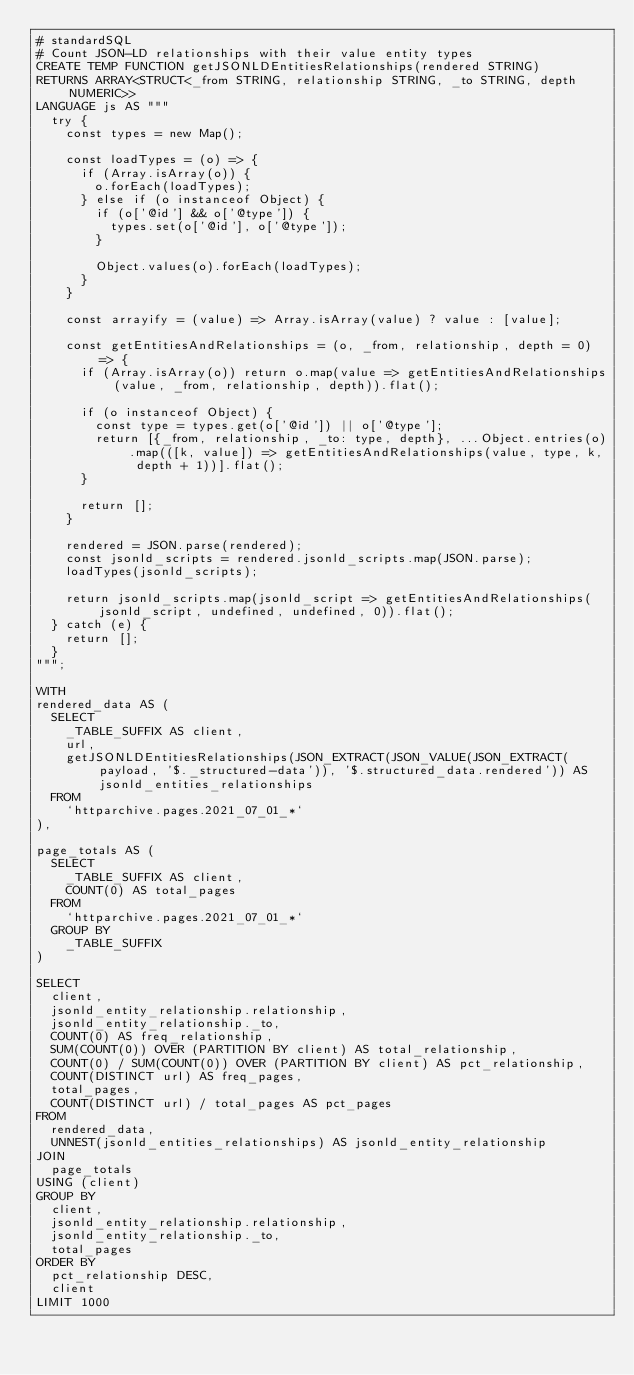<code> <loc_0><loc_0><loc_500><loc_500><_SQL_># standardSQL
# Count JSON-LD relationships with their value entity types
CREATE TEMP FUNCTION getJSONLDEntitiesRelationships(rendered STRING)
RETURNS ARRAY<STRUCT<_from STRING, relationship STRING, _to STRING, depth NUMERIC>>
LANGUAGE js AS """
  try {
    const types = new Map();

    const loadTypes = (o) => {
      if (Array.isArray(o)) {
        o.forEach(loadTypes);
      } else if (o instanceof Object) {
        if (o['@id'] && o['@type']) {
          types.set(o['@id'], o['@type']);
        }

        Object.values(o).forEach(loadTypes);
      }
    }

    const arrayify = (value) => Array.isArray(value) ? value : [value];

    const getEntitiesAndRelationships = (o, _from, relationship, depth = 0) => {
      if (Array.isArray(o)) return o.map(value => getEntitiesAndRelationships(value, _from, relationship, depth)).flat();

      if (o instanceof Object) {
        const type = types.get(o['@id']) || o['@type'];
        return [{_from, relationship, _to: type, depth}, ...Object.entries(o).map(([k, value]) => getEntitiesAndRelationships(value, type, k, depth + 1))].flat();
      }

      return [];
    }

    rendered = JSON.parse(rendered);
    const jsonld_scripts = rendered.jsonld_scripts.map(JSON.parse);
    loadTypes(jsonld_scripts);

    return jsonld_scripts.map(jsonld_script => getEntitiesAndRelationships(jsonld_script, undefined, undefined, 0)).flat();
  } catch (e) {
    return [];
  }
""";

WITH
rendered_data AS (
  SELECT
    _TABLE_SUFFIX AS client,
    url,
    getJSONLDEntitiesRelationships(JSON_EXTRACT(JSON_VALUE(JSON_EXTRACT(payload, '$._structured-data')), '$.structured_data.rendered')) AS jsonld_entities_relationships
  FROM
    `httparchive.pages.2021_07_01_*`
),

page_totals AS (
  SELECT
    _TABLE_SUFFIX AS client,
    COUNT(0) AS total_pages
  FROM
    `httparchive.pages.2021_07_01_*`
  GROUP BY
    _TABLE_SUFFIX
)

SELECT
  client,
  jsonld_entity_relationship.relationship,
  jsonld_entity_relationship._to,
  COUNT(0) AS freq_relationship,
  SUM(COUNT(0)) OVER (PARTITION BY client) AS total_relationship,
  COUNT(0) / SUM(COUNT(0)) OVER (PARTITION BY client) AS pct_relationship,
  COUNT(DISTINCT url) AS freq_pages,
  total_pages,
  COUNT(DISTINCT url) / total_pages AS pct_pages
FROM
  rendered_data,
  UNNEST(jsonld_entities_relationships) AS jsonld_entity_relationship
JOIN
  page_totals
USING (client)
GROUP BY
  client,
  jsonld_entity_relationship.relationship,
  jsonld_entity_relationship._to,
  total_pages
ORDER BY
  pct_relationship DESC,
  client
LIMIT 1000
</code> 